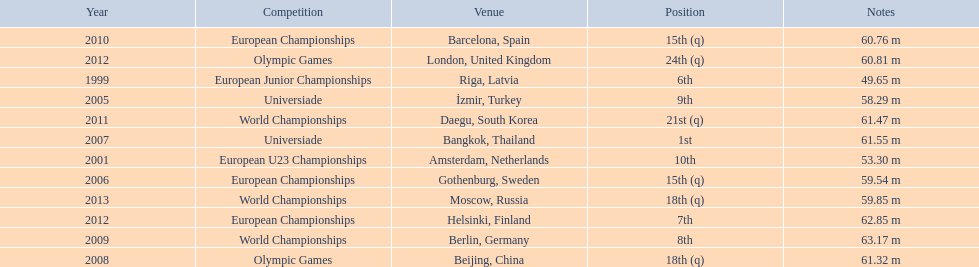Parse the table in full. {'header': ['Year', 'Competition', 'Venue', 'Position', 'Notes'], 'rows': [['2010', 'European Championships', 'Barcelona, Spain', '15th (q)', '60.76 m'], ['2012', 'Olympic Games', 'London, United Kingdom', '24th (q)', '60.81 m'], ['1999', 'European Junior Championships', 'Riga, Latvia', '6th', '49.65 m'], ['2005', 'Universiade', 'İzmir, Turkey', '9th', '58.29 m'], ['2011', 'World Championships', 'Daegu, South Korea', '21st (q)', '61.47 m'], ['2007', 'Universiade', 'Bangkok, Thailand', '1st', '61.55 m'], ['2001', 'European U23 Championships', 'Amsterdam, Netherlands', '10th', '53.30 m'], ['2006', 'European Championships', 'Gothenburg, Sweden', '15th (q)', '59.54 m'], ['2013', 'World Championships', 'Moscow, Russia', '18th (q)', '59.85 m'], ['2012', 'European Championships', 'Helsinki, Finland', '7th', '62.85 m'], ['2009', 'World Championships', 'Berlin, Germany', '8th', '63.17 m'], ['2008', 'Olympic Games', 'Beijing, China', '18th (q)', '61.32 m']]} How many world championships has he been in? 3. 